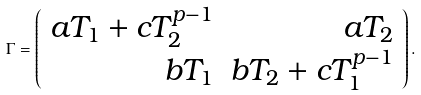<formula> <loc_0><loc_0><loc_500><loc_500>\Gamma = \left ( \begin{array} { r r } a T _ { 1 } + c T _ { 2 } ^ { p - 1 } & a T _ { 2 } \\ b T _ { 1 } & b T _ { 2 } + c T _ { 1 } ^ { p - 1 } \end{array} \right ) .</formula> 